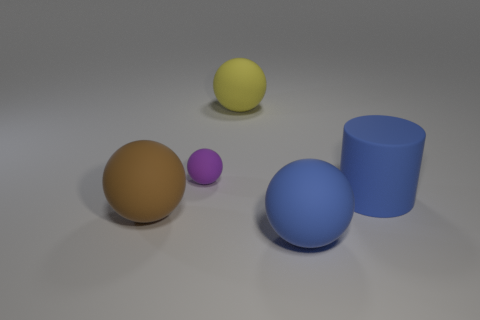Subtract 1 spheres. How many spheres are left? 3 Subtract all cyan spheres. Subtract all purple cylinders. How many spheres are left? 4 Add 4 blue rubber things. How many objects exist? 9 Subtract all balls. How many objects are left? 1 Add 3 small brown rubber cylinders. How many small brown rubber cylinders exist? 3 Subtract 0 red blocks. How many objects are left? 5 Subtract all small yellow balls. Subtract all blue matte cylinders. How many objects are left? 4 Add 3 small rubber balls. How many small rubber balls are left? 4 